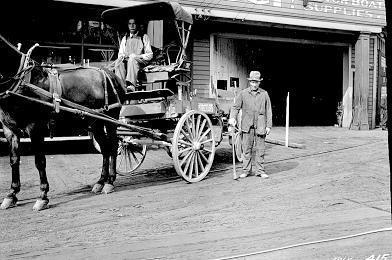How many wheels does the carriage have?
Give a very brief answer. 2. How many people are riding the carriage?
Give a very brief answer. 1. 